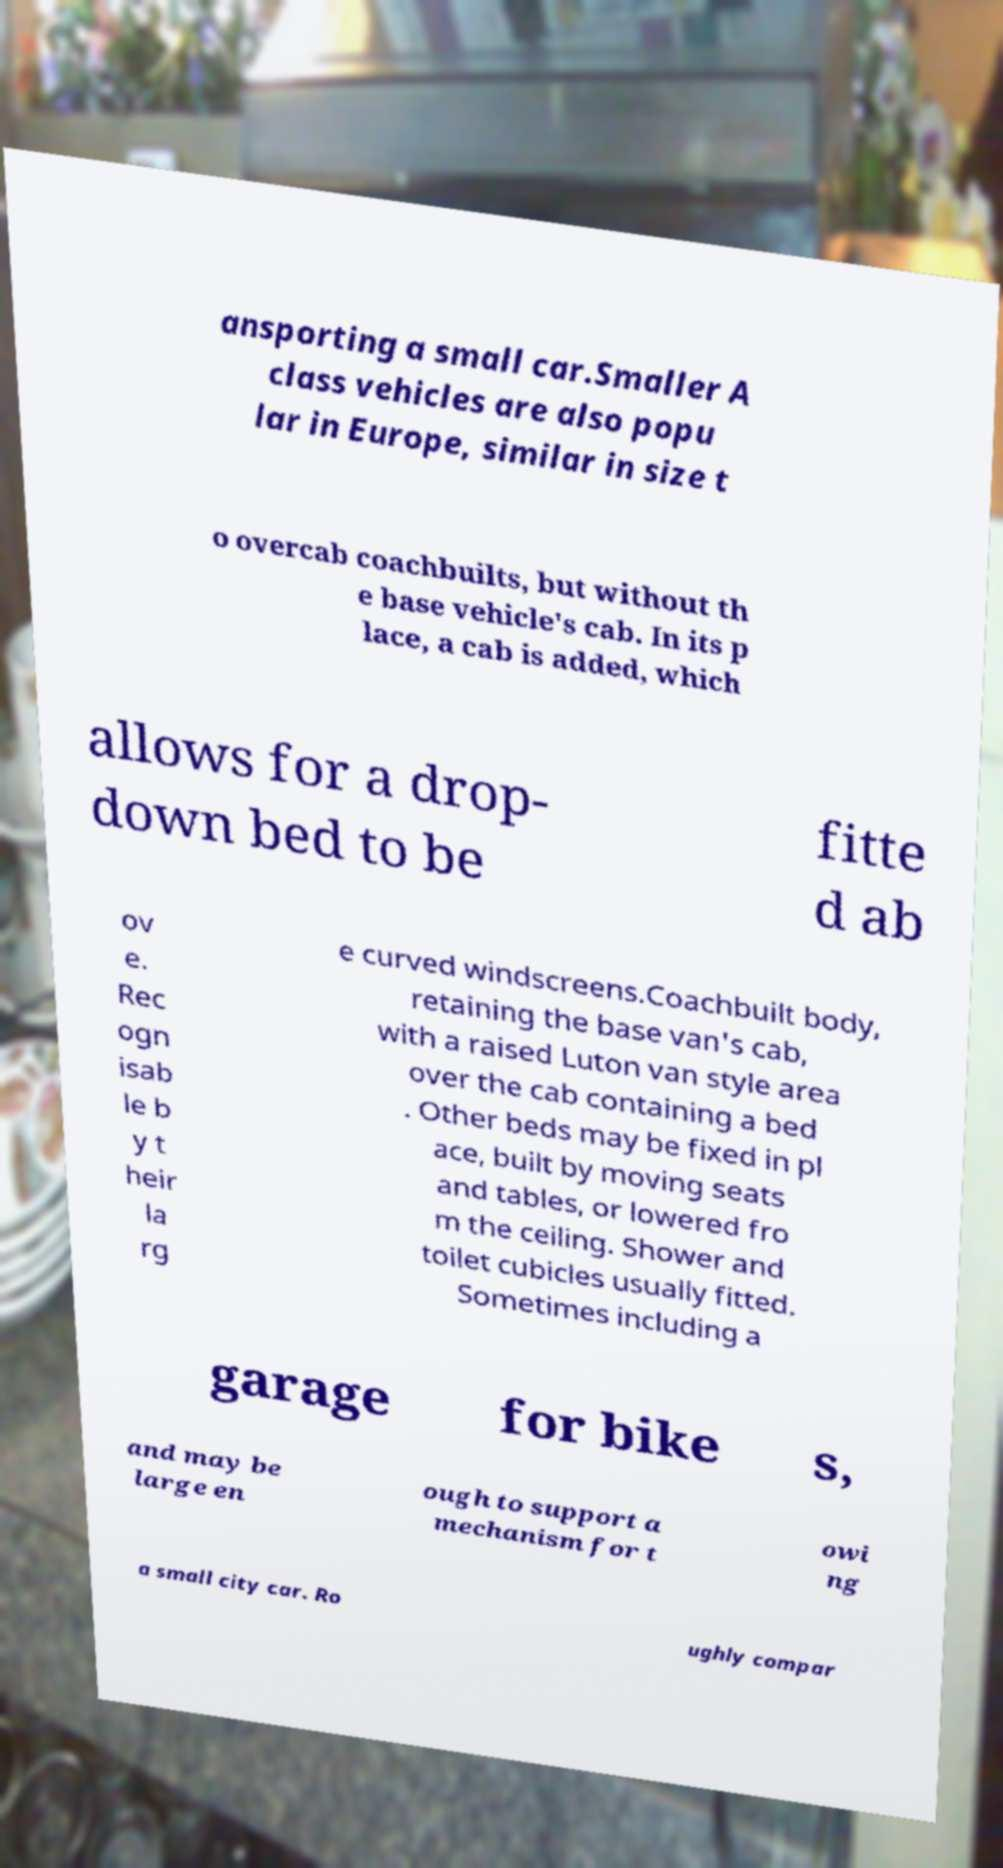Please read and relay the text visible in this image. What does it say? ansporting a small car.Smaller A class vehicles are also popu lar in Europe, similar in size t o overcab coachbuilts, but without th e base vehicle's cab. In its p lace, a cab is added, which allows for a drop- down bed to be fitte d ab ov e. Rec ogn isab le b y t heir la rg e curved windscreens.Coachbuilt body, retaining the base van's cab, with a raised Luton van style area over the cab containing a bed . Other beds may be fixed in pl ace, built by moving seats and tables, or lowered fro m the ceiling. Shower and toilet cubicles usually fitted. Sometimes including a garage for bike s, and may be large en ough to support a mechanism for t owi ng a small city car. Ro ughly compar 